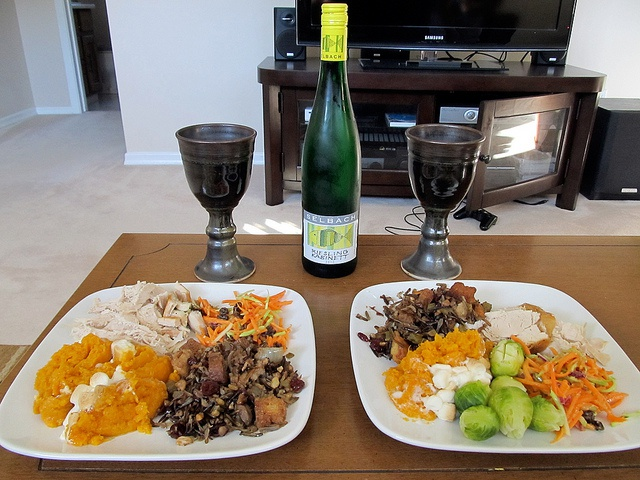Describe the objects in this image and their specific colors. I can see dining table in gray, lightgray, brown, and maroon tones, tv in gray, black, and darkgray tones, bottle in gray, black, darkgreen, and lightgray tones, tv in gray, darkgray, black, and white tones, and wine glass in gray, black, and darkgray tones in this image. 